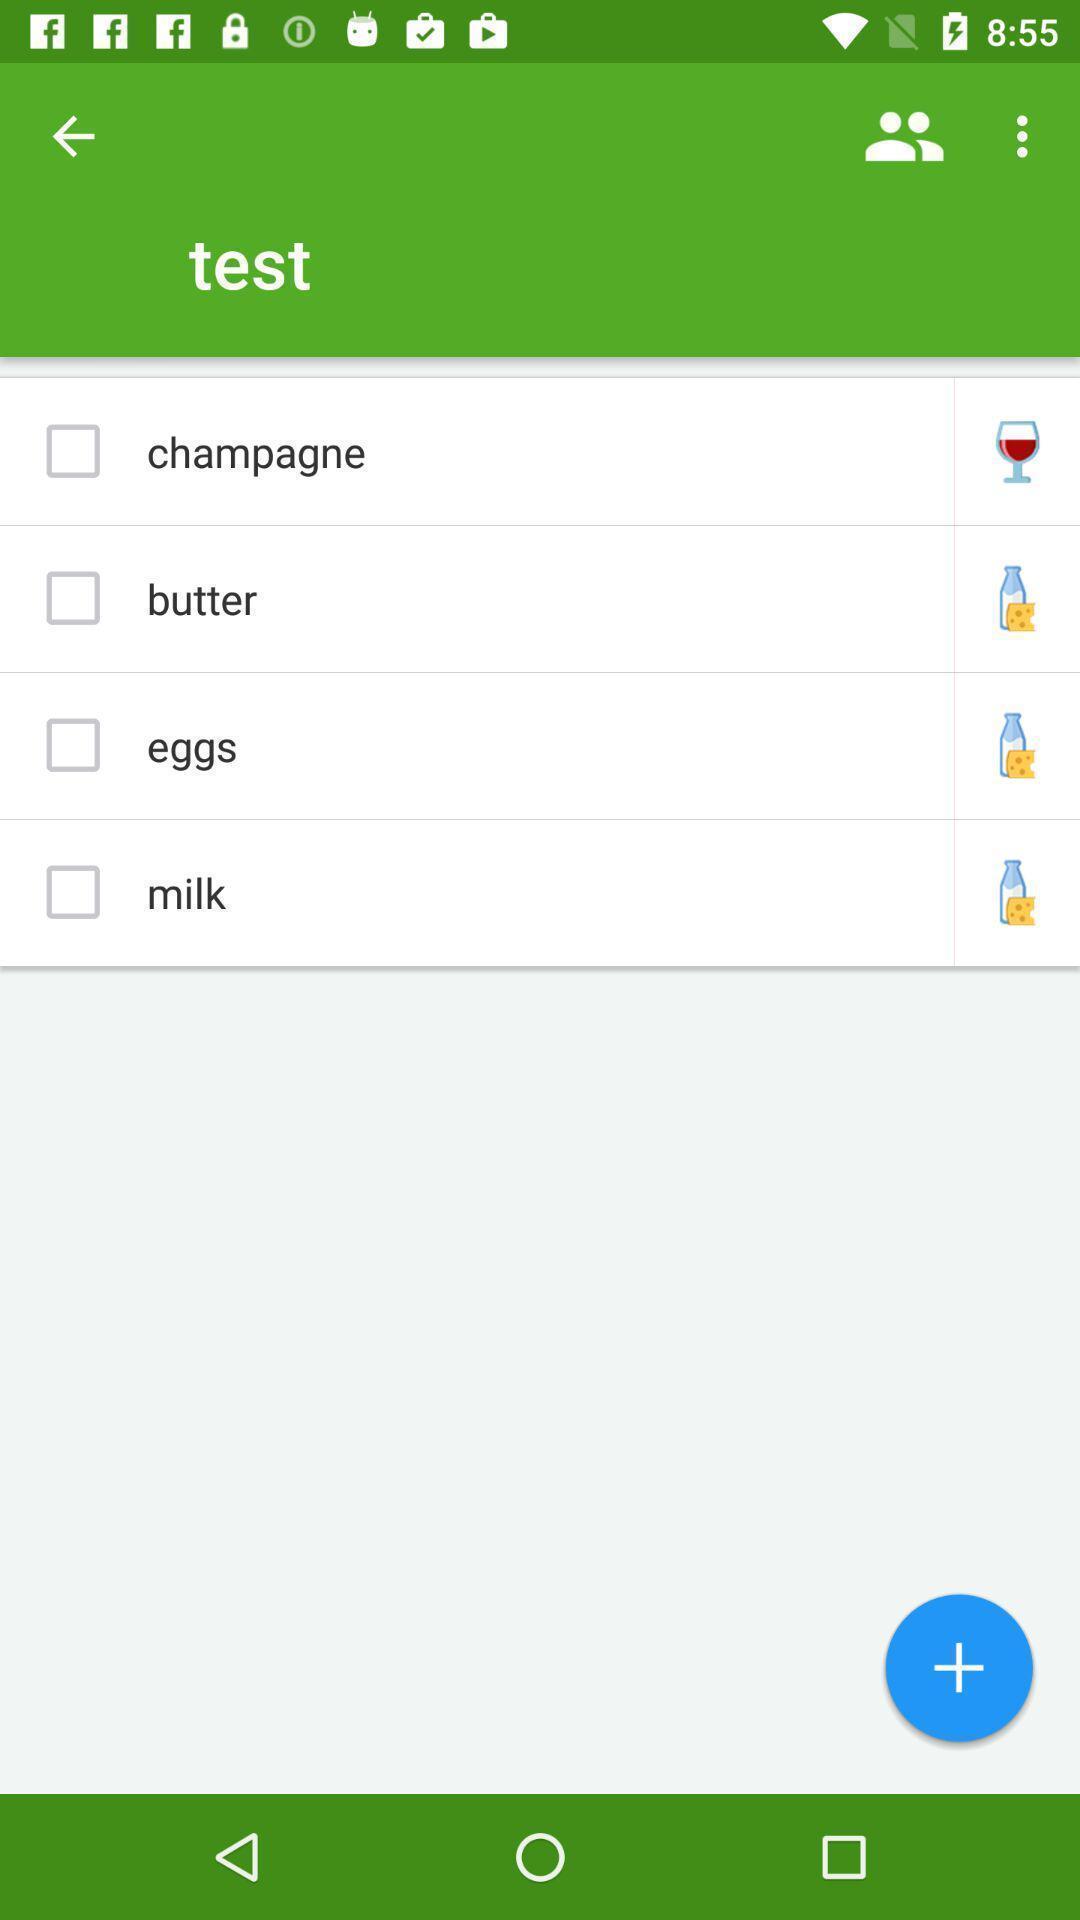Summarize the main components in this picture. Screen shows different groceries in shopping app. 